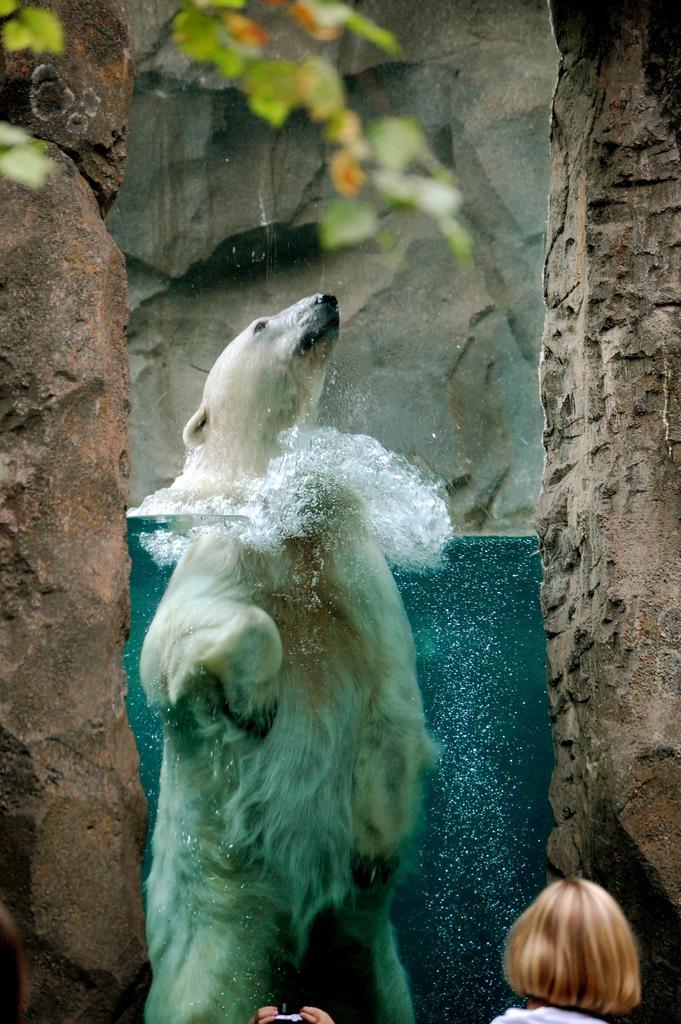How would you summarize this image in a sentence or two? In this image we can see an animal, water, rocks, and leaves. At the bottom of the image we can see a person who is truncated. 